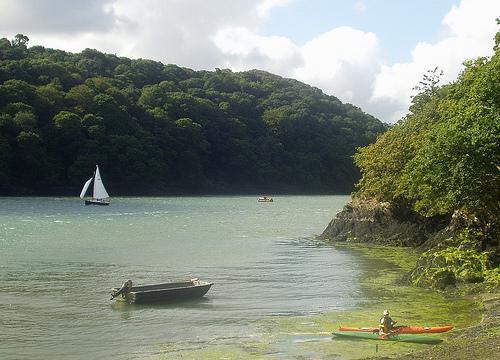How many boats are in the water?
Give a very brief answer. 4. 